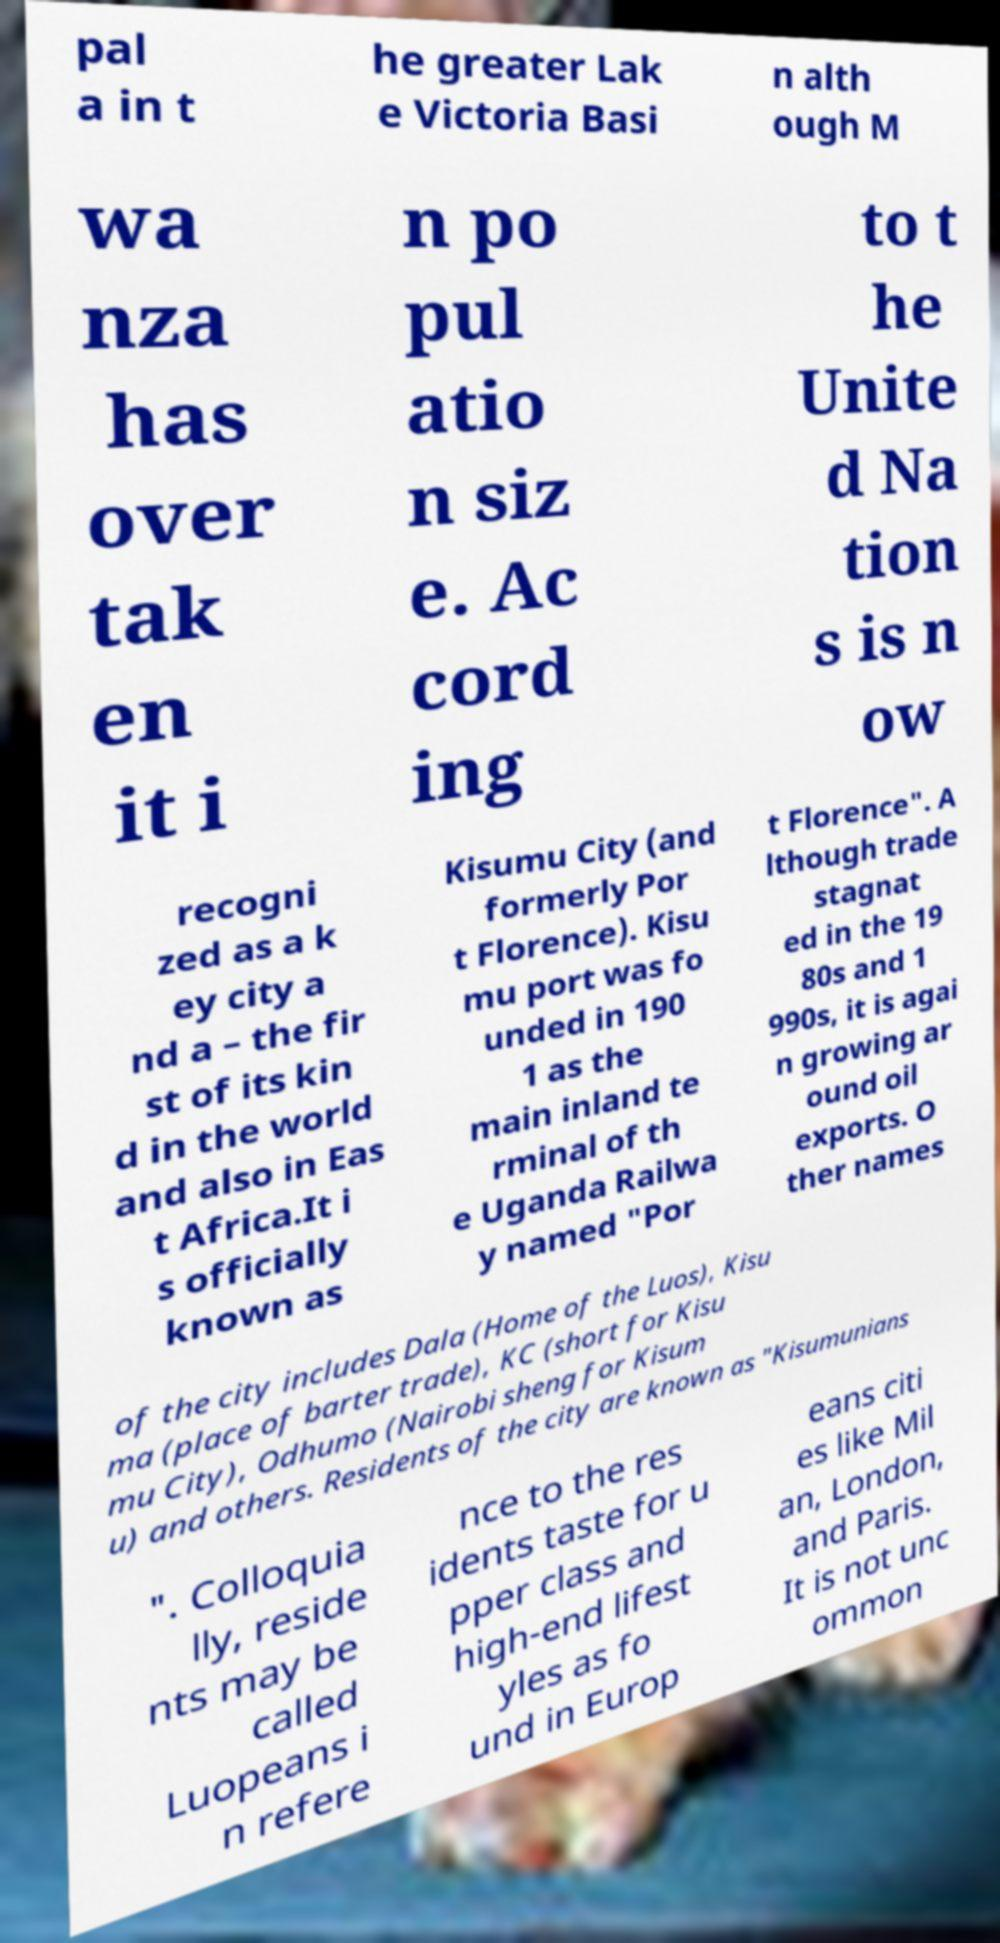Could you extract and type out the text from this image? pal a in t he greater Lak e Victoria Basi n alth ough M wa nza has over tak en it i n po pul atio n siz e. Ac cord ing to t he Unite d Na tion s is n ow recogni zed as a k ey city a nd a – the fir st of its kin d in the world and also in Eas t Africa.It i s officially known as Kisumu City (and formerly Por t Florence). Kisu mu port was fo unded in 190 1 as the main inland te rminal of th e Uganda Railwa y named "Por t Florence". A lthough trade stagnat ed in the 19 80s and 1 990s, it is agai n growing ar ound oil exports. O ther names of the city includes Dala (Home of the Luos), Kisu ma (place of barter trade), KC (short for Kisu mu City), Odhumo (Nairobi sheng for Kisum u) and others. Residents of the city are known as "Kisumunians ". Colloquia lly, reside nts may be called Luopeans i n refere nce to the res idents taste for u pper class and high-end lifest yles as fo und in Europ eans citi es like Mil an, London, and Paris. It is not unc ommon 